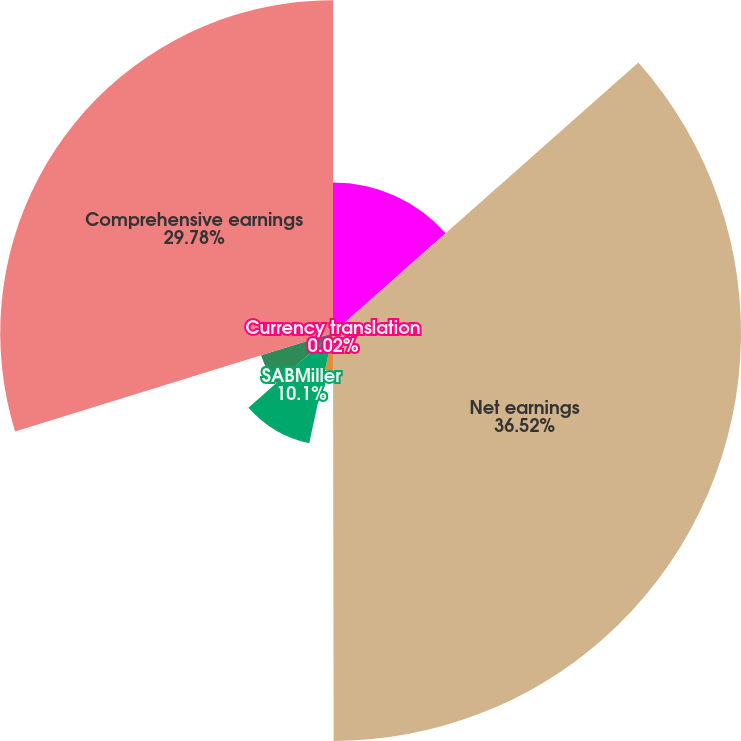Convert chart to OTSL. <chart><loc_0><loc_0><loc_500><loc_500><pie_chart><fcel>for the years ended December<fcel>Net earnings<fcel>Currency translation<fcel>Benefit plans<fcel>SABMiller<fcel>Other comprehensive earnings<fcel>Comprehensive earnings<nl><fcel>13.46%<fcel>36.51%<fcel>0.02%<fcel>3.38%<fcel>10.1%<fcel>6.74%<fcel>29.78%<nl></chart> 